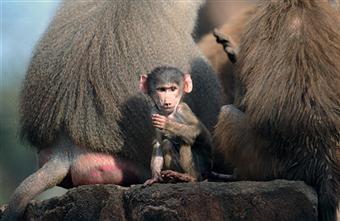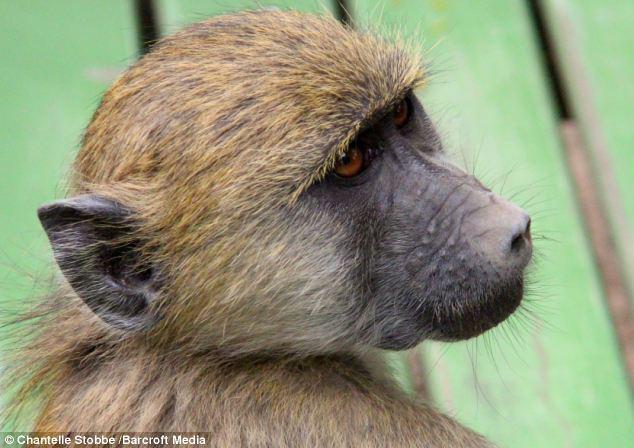The first image is the image on the left, the second image is the image on the right. Evaluate the accuracy of this statement regarding the images: "An image shows a juvenile baboon posed with its chest against the chest of an adult baboon.". Is it true? Answer yes or no. No. The first image is the image on the left, the second image is the image on the right. For the images shown, is this caption "There is a single monkey looking in the direction of the camera in the image on the right." true? Answer yes or no. No. 